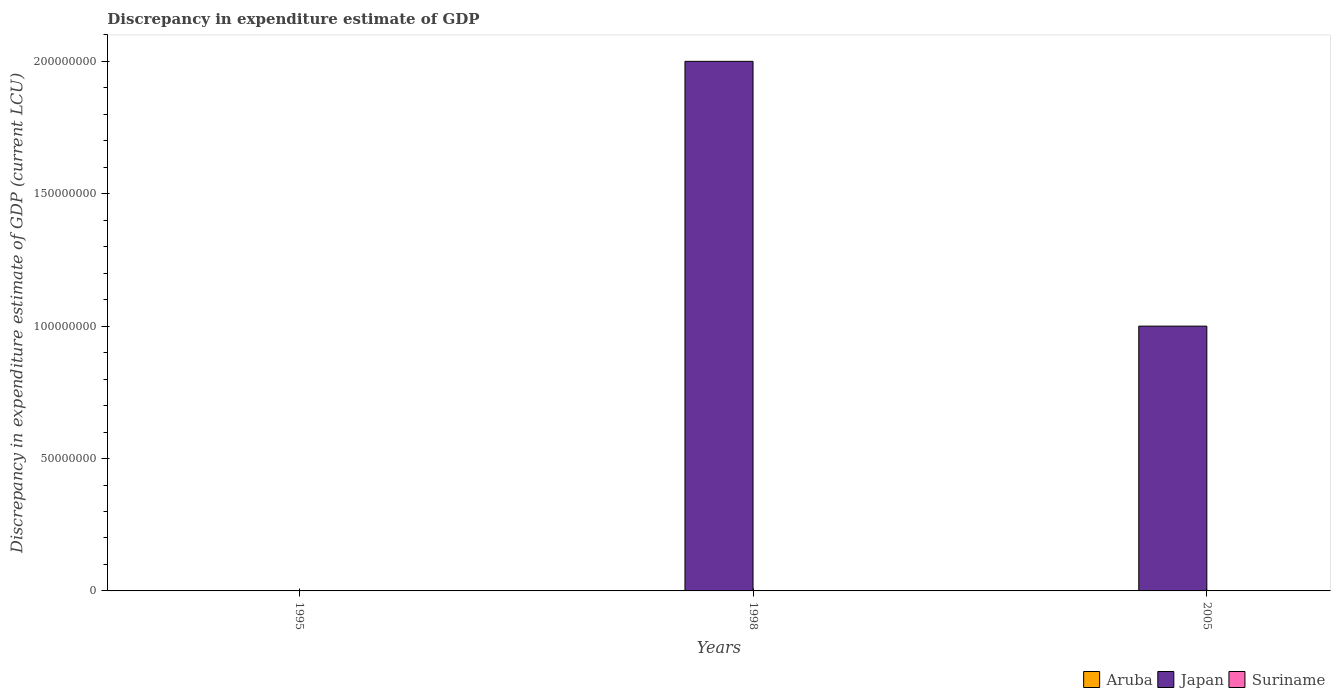How many different coloured bars are there?
Provide a short and direct response. 3. Are the number of bars on each tick of the X-axis equal?
Make the answer very short. No. How many bars are there on the 1st tick from the left?
Ensure brevity in your answer.  1. How many bars are there on the 3rd tick from the right?
Your answer should be very brief. 1. What is the label of the 3rd group of bars from the left?
Ensure brevity in your answer.  2005. In how many cases, is the number of bars for a given year not equal to the number of legend labels?
Make the answer very short. 2. What is the discrepancy in expenditure estimate of GDP in Suriname in 1998?
Offer a very short reply. 0. Across all years, what is the minimum discrepancy in expenditure estimate of GDP in Japan?
Provide a succinct answer. 0. In which year was the discrepancy in expenditure estimate of GDP in Japan maximum?
Your response must be concise. 1998. What is the total discrepancy in expenditure estimate of GDP in Japan in the graph?
Your response must be concise. 3.00e+08. What is the difference between the discrepancy in expenditure estimate of GDP in Suriname in 1995 and that in 2005?
Your answer should be compact. 4.69e+04. What is the difference between the discrepancy in expenditure estimate of GDP in Aruba in 2005 and the discrepancy in expenditure estimate of GDP in Japan in 1998?
Offer a terse response. -2.00e+08. What is the average discrepancy in expenditure estimate of GDP in Suriname per year?
Provide a short and direct response. 1.57e+04. In the year 2005, what is the difference between the discrepancy in expenditure estimate of GDP in Aruba and discrepancy in expenditure estimate of GDP in Suriname?
Your answer should be very brief. 9900. In how many years, is the discrepancy in expenditure estimate of GDP in Japan greater than 200000000 LCU?
Keep it short and to the point. 0. What is the difference between the highest and the lowest discrepancy in expenditure estimate of GDP in Aruba?
Give a very brief answer. 10000. Is the sum of the discrepancy in expenditure estimate of GDP in Suriname in 1995 and 2005 greater than the maximum discrepancy in expenditure estimate of GDP in Aruba across all years?
Ensure brevity in your answer.  Yes. Is it the case that in every year, the sum of the discrepancy in expenditure estimate of GDP in Suriname and discrepancy in expenditure estimate of GDP in Aruba is greater than the discrepancy in expenditure estimate of GDP in Japan?
Give a very brief answer. No. How many bars are there?
Provide a succinct answer. 5. Are all the bars in the graph horizontal?
Your response must be concise. No. Does the graph contain any zero values?
Provide a succinct answer. Yes. Does the graph contain grids?
Provide a short and direct response. No. How many legend labels are there?
Give a very brief answer. 3. How are the legend labels stacked?
Keep it short and to the point. Horizontal. What is the title of the graph?
Keep it short and to the point. Discrepancy in expenditure estimate of GDP. Does "Sao Tome and Principe" appear as one of the legend labels in the graph?
Ensure brevity in your answer.  No. What is the label or title of the Y-axis?
Give a very brief answer. Discrepancy in expenditure estimate of GDP (current LCU). What is the Discrepancy in expenditure estimate of GDP (current LCU) of Japan in 1995?
Provide a succinct answer. 0. What is the Discrepancy in expenditure estimate of GDP (current LCU) in Suriname in 1995?
Make the answer very short. 4.70e+04. What is the Discrepancy in expenditure estimate of GDP (current LCU) of Japan in 1998?
Your answer should be very brief. 2.00e+08. What is the Discrepancy in expenditure estimate of GDP (current LCU) in Suriname in 1998?
Keep it short and to the point. 0. What is the Discrepancy in expenditure estimate of GDP (current LCU) of Aruba in 2005?
Offer a terse response. 10000. What is the Discrepancy in expenditure estimate of GDP (current LCU) in Japan in 2005?
Offer a terse response. 1.00e+08. Across all years, what is the maximum Discrepancy in expenditure estimate of GDP (current LCU) of Japan?
Your response must be concise. 2.00e+08. Across all years, what is the maximum Discrepancy in expenditure estimate of GDP (current LCU) in Suriname?
Offer a very short reply. 4.70e+04. Across all years, what is the minimum Discrepancy in expenditure estimate of GDP (current LCU) in Suriname?
Your answer should be compact. 0. What is the total Discrepancy in expenditure estimate of GDP (current LCU) of Japan in the graph?
Give a very brief answer. 3.00e+08. What is the total Discrepancy in expenditure estimate of GDP (current LCU) of Suriname in the graph?
Ensure brevity in your answer.  4.71e+04. What is the difference between the Discrepancy in expenditure estimate of GDP (current LCU) in Suriname in 1995 and that in 2005?
Your response must be concise. 4.69e+04. What is the difference between the Discrepancy in expenditure estimate of GDP (current LCU) in Japan in 1998 and that in 2005?
Provide a short and direct response. 1.00e+08. What is the difference between the Discrepancy in expenditure estimate of GDP (current LCU) in Japan in 1998 and the Discrepancy in expenditure estimate of GDP (current LCU) in Suriname in 2005?
Your answer should be very brief. 2.00e+08. What is the average Discrepancy in expenditure estimate of GDP (current LCU) in Aruba per year?
Keep it short and to the point. 3333.33. What is the average Discrepancy in expenditure estimate of GDP (current LCU) in Japan per year?
Offer a very short reply. 1.00e+08. What is the average Discrepancy in expenditure estimate of GDP (current LCU) in Suriname per year?
Make the answer very short. 1.57e+04. In the year 2005, what is the difference between the Discrepancy in expenditure estimate of GDP (current LCU) in Aruba and Discrepancy in expenditure estimate of GDP (current LCU) in Japan?
Your response must be concise. -1.00e+08. In the year 2005, what is the difference between the Discrepancy in expenditure estimate of GDP (current LCU) of Aruba and Discrepancy in expenditure estimate of GDP (current LCU) of Suriname?
Your answer should be compact. 9900. In the year 2005, what is the difference between the Discrepancy in expenditure estimate of GDP (current LCU) in Japan and Discrepancy in expenditure estimate of GDP (current LCU) in Suriname?
Offer a terse response. 1.00e+08. What is the ratio of the Discrepancy in expenditure estimate of GDP (current LCU) of Suriname in 1995 to that in 2005?
Provide a succinct answer. 470. What is the ratio of the Discrepancy in expenditure estimate of GDP (current LCU) of Japan in 1998 to that in 2005?
Keep it short and to the point. 2. What is the difference between the highest and the lowest Discrepancy in expenditure estimate of GDP (current LCU) of Aruba?
Offer a very short reply. 10000. What is the difference between the highest and the lowest Discrepancy in expenditure estimate of GDP (current LCU) in Japan?
Offer a very short reply. 2.00e+08. What is the difference between the highest and the lowest Discrepancy in expenditure estimate of GDP (current LCU) of Suriname?
Provide a short and direct response. 4.70e+04. 